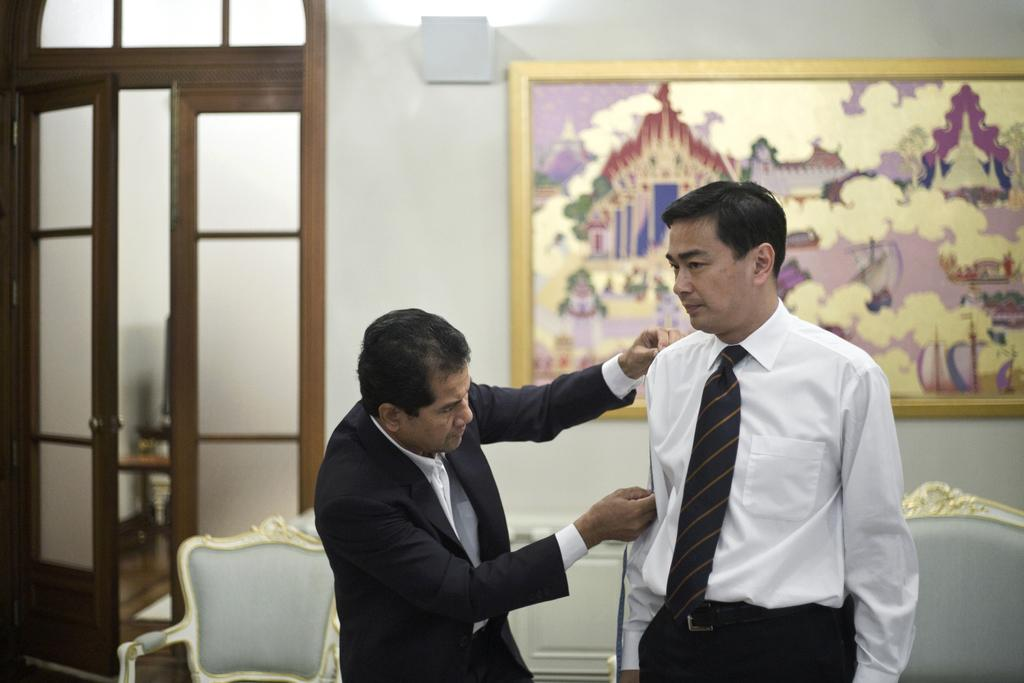What is happening on the right side of the image? There is a man standing on the right side of the image, and another man is measuring the body of the person on the right side. What can be seen in the background of the image? There are chairs, doors, and a frame on the wall in the background of the image. What advice is the man giving to the person on the right side of the image? There is no indication in the image that the man is giving advice to the person on the right side. What type of attraction can be seen in the background of the image? There is no attraction present in the image; it only shows a man measuring the body of the person on the right side, chairs, doors, and a frame on the wall in the background. 